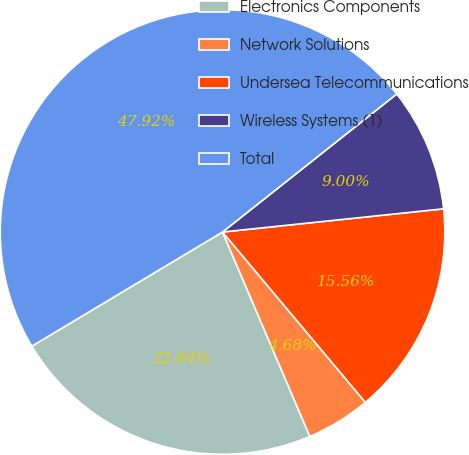Convert chart to OTSL. <chart><loc_0><loc_0><loc_500><loc_500><pie_chart><fcel>Electronics Components<fcel>Network Solutions<fcel>Undersea Telecommunications<fcel>Wireless Systems (1)<fcel>Total<nl><fcel>22.84%<fcel>4.68%<fcel>15.56%<fcel>9.0%<fcel>47.92%<nl></chart> 